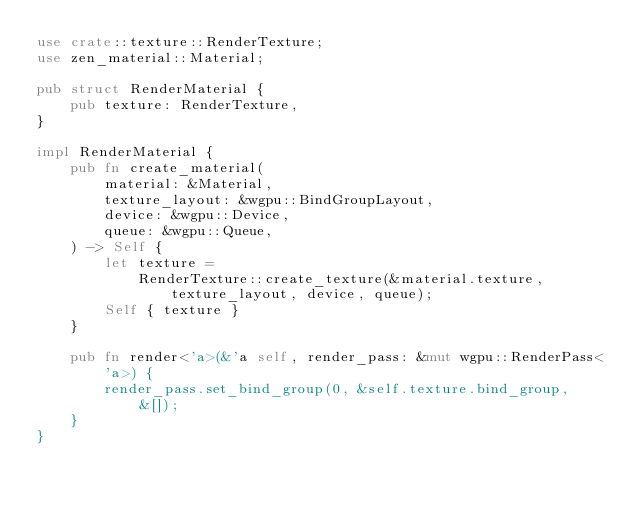Convert code to text. <code><loc_0><loc_0><loc_500><loc_500><_Rust_>use crate::texture::RenderTexture;
use zen_material::Material;

pub struct RenderMaterial {
    pub texture: RenderTexture,
}

impl RenderMaterial {
    pub fn create_material(
        material: &Material,
        texture_layout: &wgpu::BindGroupLayout,
        device: &wgpu::Device,
        queue: &wgpu::Queue,
    ) -> Self {
        let texture =
            RenderTexture::create_texture(&material.texture, texture_layout, device, queue);
        Self { texture }
    }

    pub fn render<'a>(&'a self, render_pass: &mut wgpu::RenderPass<'a>) {
        render_pass.set_bind_group(0, &self.texture.bind_group, &[]);
    }
}
</code> 